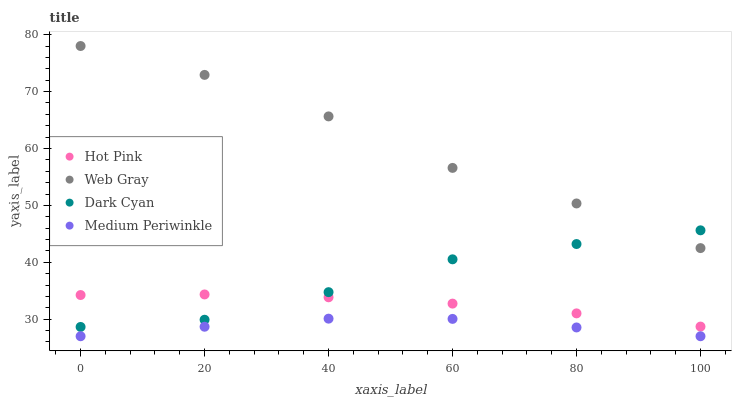Does Medium Periwinkle have the minimum area under the curve?
Answer yes or no. Yes. Does Web Gray have the maximum area under the curve?
Answer yes or no. Yes. Does Hot Pink have the minimum area under the curve?
Answer yes or no. No. Does Hot Pink have the maximum area under the curve?
Answer yes or no. No. Is Hot Pink the smoothest?
Answer yes or no. Yes. Is Web Gray the roughest?
Answer yes or no. Yes. Is Medium Periwinkle the smoothest?
Answer yes or no. No. Is Medium Periwinkle the roughest?
Answer yes or no. No. Does Medium Periwinkle have the lowest value?
Answer yes or no. Yes. Does Hot Pink have the lowest value?
Answer yes or no. No. Does Web Gray have the highest value?
Answer yes or no. Yes. Does Hot Pink have the highest value?
Answer yes or no. No. Is Medium Periwinkle less than Hot Pink?
Answer yes or no. Yes. Is Hot Pink greater than Medium Periwinkle?
Answer yes or no. Yes. Does Dark Cyan intersect Web Gray?
Answer yes or no. Yes. Is Dark Cyan less than Web Gray?
Answer yes or no. No. Is Dark Cyan greater than Web Gray?
Answer yes or no. No. Does Medium Periwinkle intersect Hot Pink?
Answer yes or no. No. 